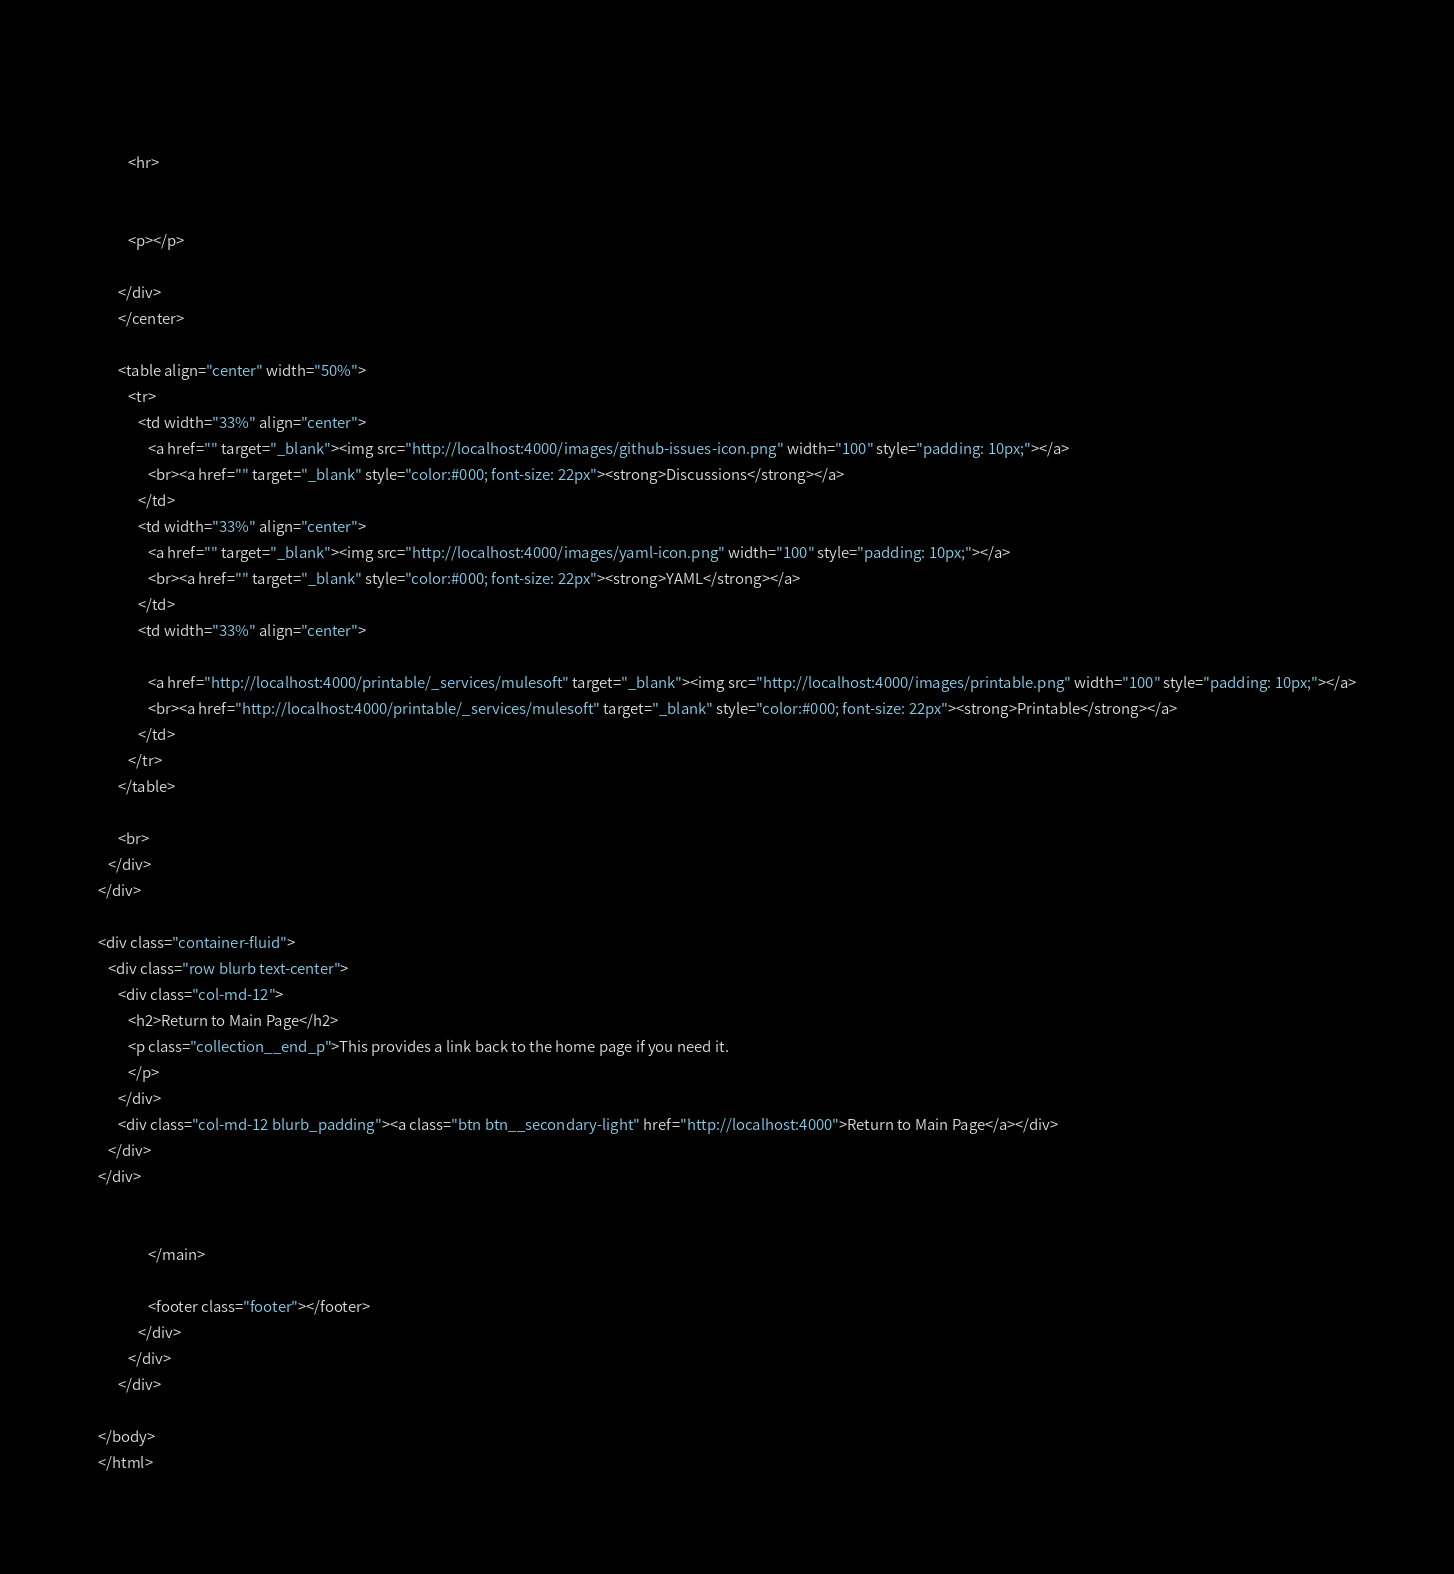Convert code to text. <code><loc_0><loc_0><loc_500><loc_500><_HTML_>         

         <hr>
             
         
         <p></p>

      </div>
      </center>

      <table align="center" width="50%">
         <tr>
            <td width="33%" align="center">
               <a href="" target="_blank"><img src="http://localhost:4000/images/github-issues-icon.png" width="100" style="padding: 10px;"></a>
               <br><a href="" target="_blank" style="color:#000; font-size: 22px"><strong>Discussions</strong></a>
            </td>
            <td width="33%" align="center">
               <a href="" target="_blank"><img src="http://localhost:4000/images/yaml-icon.png" width="100" style="padding: 10px;"></a>
               <br><a href="" target="_blank" style="color:#000; font-size: 22px"><strong>YAML</strong></a>
            </td>
            <td width="33%" align="center">
                              
               <a href="http://localhost:4000/printable/_services/mulesoft" target="_blank"><img src="http://localhost:4000/images/printable.png" width="100" style="padding: 10px;"></a>
               <br><a href="http://localhost:4000/printable/_services/mulesoft" target="_blank" style="color:#000; font-size: 22px"><strong>Printable</strong></a>
            </td>            
         </tr>         
      </table>       
      
      <br>
   </div>
</div>

<div class="container-fluid">
   <div class="row blurb text-center">
      <div class="col-md-12">
         <h2>Return to Main Page</h2>
         <p class="collection__end_p">This provides a link back to the home page if you need it.
         </p>
      </div>
      <div class="col-md-12 blurb_padding"><a class="btn btn__secondary-light" href="http://localhost:4000">Return to Main Page</a></div>
   </div>
</div>


               </main>

               <footer class="footer"></footer>
            </div>
         </div>
      </div>

</body>
</html>
</code> 